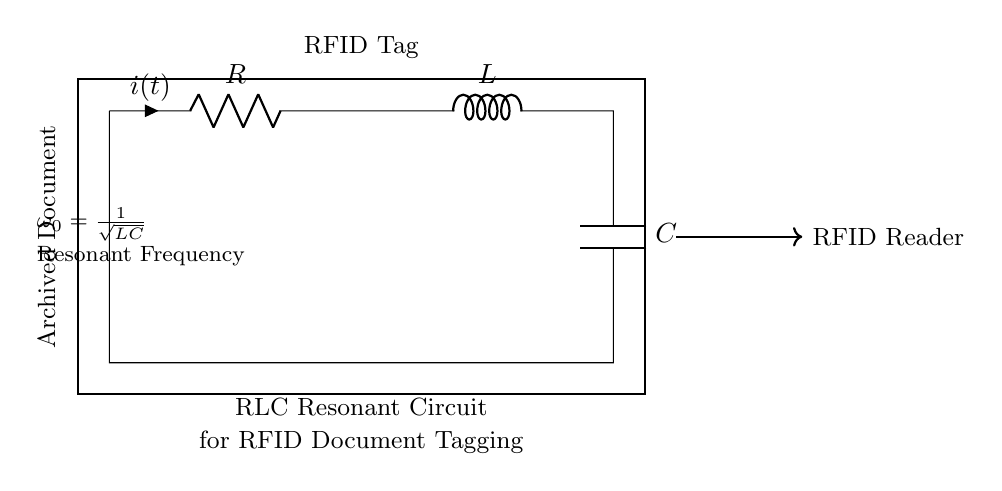What are the components of this circuit? The circuit contains a resistor, inductor, and capacitor, as labeled in the diagram.
Answer: Resistor, Inductor, Capacitor What does the symbol “R” represent? The symbol “R” in the circuit diagram represents a resistor, which is used to limit current.
Answer: Resistor What is connected to the bottom terminal of the capacitor? The bottom terminal of the capacitor is connected back to the starting point of the circuit, completing the loop.
Answer: Ground What is the meaning of the resonant frequency formula given? The resonant frequency formula $\omega_0 = \frac{1}{\sqrt{LC}}$ indicates that the circuit can oscillate at a specific frequency, determined by the inductor's value (L) and the capacitor's value (C).
Answer: Resonant frequency formula What happens to the circuit at the resonant frequency? At the resonant frequency, the impedance of the circuit is minimized, maximizing current flow and allowing effective RFID tagging.
Answer: Maximum current flow What is the function of the RFID tag in this circuit? The RFID tag functions as a transmitter that communicates with the RFID reader, allowing for the identification of archived documents.
Answer: Identification of documents What does the arrow pointing to the RFID reader indicate? The arrow indicates the flow of a signal or communication from the RLC circuit to the RFID reader, showing interaction between them.
Answer: Signal flow 